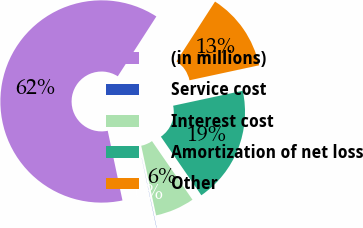Convert chart. <chart><loc_0><loc_0><loc_500><loc_500><pie_chart><fcel>(in millions)<fcel>Service cost<fcel>Interest cost<fcel>Amortization of net loss<fcel>Other<nl><fcel>62.43%<fcel>0.03%<fcel>6.27%<fcel>18.75%<fcel>12.51%<nl></chart> 